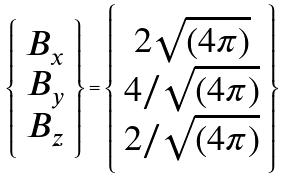<formula> <loc_0><loc_0><loc_500><loc_500>\left \{ \begin{array} { c } B _ { x } \\ B _ { y } \\ B _ { z } \end{array} \right \} = \left \{ \begin{array} { c } 2 \sqrt { ( 4 \pi ) } \\ 4 / \sqrt { ( 4 \pi ) } \\ 2 / \sqrt { ( 4 \pi ) } \end{array} \right \}</formula> 